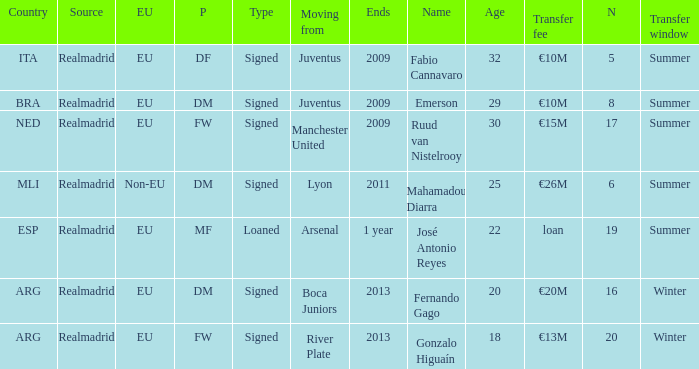What is the EU status of ESP? EU. Help me parse the entirety of this table. {'header': ['Country', 'Source', 'EU', 'P', 'Type', 'Moving from', 'Ends', 'Name', 'Age', 'Transfer fee', 'N', 'Transfer window'], 'rows': [['ITA', 'Realmadrid', 'EU', 'DF', 'Signed', 'Juventus', '2009', 'Fabio Cannavaro', '32', '€10M', '5', 'Summer'], ['BRA', 'Realmadrid', 'EU', 'DM', 'Signed', 'Juventus', '2009', 'Emerson', '29', '€10M', '8', 'Summer'], ['NED', 'Realmadrid', 'EU', 'FW', 'Signed', 'Manchester United', '2009', 'Ruud van Nistelrooy', '30', '€15M', '17', 'Summer'], ['MLI', 'Realmadrid', 'Non-EU', 'DM', 'Signed', 'Lyon', '2011', 'Mahamadou Diarra', '25', '€26M', '6', 'Summer'], ['ESP', 'Realmadrid', 'EU', 'MF', 'Loaned', 'Arsenal', '1 year', 'José Antonio Reyes', '22', 'loan', '19', 'Summer'], ['ARG', 'Realmadrid', 'EU', 'DM', 'Signed', 'Boca Juniors', '2013', 'Fernando Gago', '20', '€20M', '16', 'Winter'], ['ARG', 'Realmadrid', 'EU', 'FW', 'Signed', 'River Plate', '2013', 'Gonzalo Higuaín', '18', '€13M', '20', 'Winter']]} 